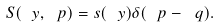<formula> <loc_0><loc_0><loc_500><loc_500>S ( \ y , \ p ) = s ( \ y ) \delta ( \ p - \ q ) .</formula> 